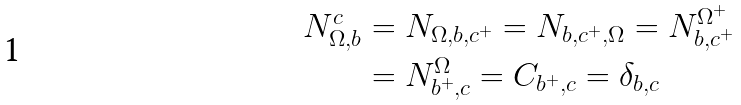Convert formula to latex. <formula><loc_0><loc_0><loc_500><loc_500>N _ { \Omega , b } ^ { c } & = N _ { \Omega , b , c ^ { + } } = N _ { b , c ^ { + } , \Omega } = N _ { b , c ^ { + } } ^ { \Omega ^ { + } } \\ & = N _ { b ^ { + } , c } ^ { \Omega } = C _ { b ^ { + } , c } = \delta _ { b , c }</formula> 